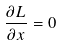<formula> <loc_0><loc_0><loc_500><loc_500>\frac { \partial L } { \partial x } = 0</formula> 